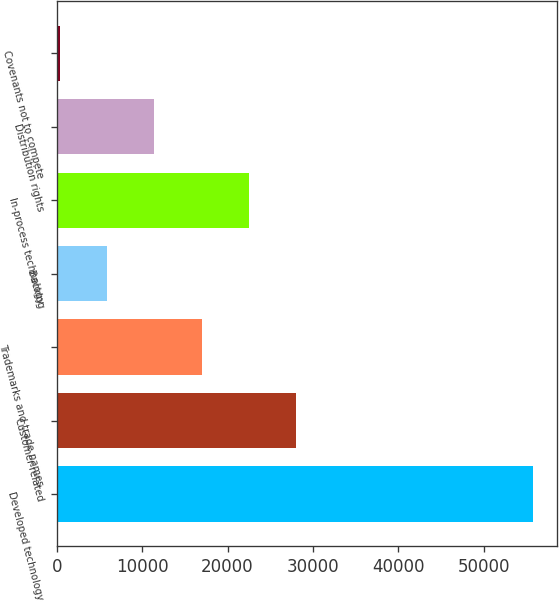<chart> <loc_0><loc_0><loc_500><loc_500><bar_chart><fcel>Developed technology<fcel>Customer-related<fcel>Trademarks and trade names<fcel>Backlog<fcel>In-process technology<fcel>Distribution rights<fcel>Covenants not to compete<nl><fcel>55757<fcel>28045.5<fcel>16960.9<fcel>5876.3<fcel>22503.2<fcel>11418.6<fcel>334<nl></chart> 